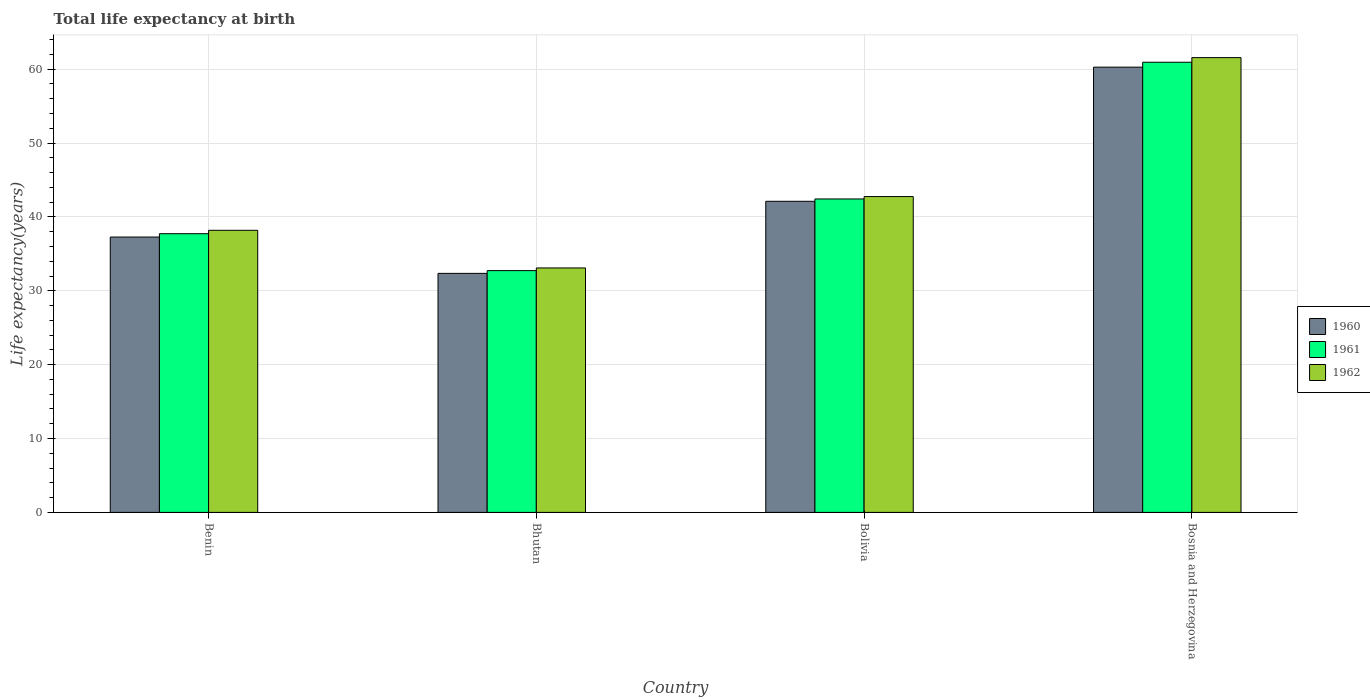Are the number of bars on each tick of the X-axis equal?
Offer a very short reply. Yes. What is the label of the 2nd group of bars from the left?
Provide a succinct answer. Bhutan. In how many cases, is the number of bars for a given country not equal to the number of legend labels?
Give a very brief answer. 0. What is the life expectancy at birth in in 1960 in Bhutan?
Your answer should be very brief. 32.36. Across all countries, what is the maximum life expectancy at birth in in 1961?
Offer a terse response. 60.94. Across all countries, what is the minimum life expectancy at birth in in 1962?
Give a very brief answer. 33.09. In which country was the life expectancy at birth in in 1961 maximum?
Ensure brevity in your answer.  Bosnia and Herzegovina. In which country was the life expectancy at birth in in 1960 minimum?
Make the answer very short. Bhutan. What is the total life expectancy at birth in in 1960 in the graph?
Your response must be concise. 172.03. What is the difference between the life expectancy at birth in in 1962 in Bhutan and that in Bolivia?
Ensure brevity in your answer.  -9.66. What is the difference between the life expectancy at birth in in 1961 in Bolivia and the life expectancy at birth in in 1962 in Bhutan?
Your answer should be very brief. 9.34. What is the average life expectancy at birth in in 1961 per country?
Your answer should be very brief. 43.46. What is the difference between the life expectancy at birth in of/in 1960 and life expectancy at birth in of/in 1961 in Benin?
Provide a short and direct response. -0.45. In how many countries, is the life expectancy at birth in in 1961 greater than 58 years?
Provide a succinct answer. 1. What is the ratio of the life expectancy at birth in in 1960 in Benin to that in Bolivia?
Ensure brevity in your answer.  0.89. Is the difference between the life expectancy at birth in in 1960 in Benin and Bosnia and Herzegovina greater than the difference between the life expectancy at birth in in 1961 in Benin and Bosnia and Herzegovina?
Ensure brevity in your answer.  Yes. What is the difference between the highest and the second highest life expectancy at birth in in 1962?
Ensure brevity in your answer.  -18.81. What is the difference between the highest and the lowest life expectancy at birth in in 1962?
Offer a very short reply. 28.47. In how many countries, is the life expectancy at birth in in 1960 greater than the average life expectancy at birth in in 1960 taken over all countries?
Offer a terse response. 1. Is the sum of the life expectancy at birth in in 1961 in Benin and Bosnia and Herzegovina greater than the maximum life expectancy at birth in in 1960 across all countries?
Give a very brief answer. Yes. Is it the case that in every country, the sum of the life expectancy at birth in in 1960 and life expectancy at birth in in 1962 is greater than the life expectancy at birth in in 1961?
Your answer should be very brief. Yes. How many bars are there?
Offer a terse response. 12. How many countries are there in the graph?
Your answer should be very brief. 4. How are the legend labels stacked?
Ensure brevity in your answer.  Vertical. What is the title of the graph?
Your answer should be very brief. Total life expectancy at birth. Does "1971" appear as one of the legend labels in the graph?
Your answer should be very brief. No. What is the label or title of the Y-axis?
Your response must be concise. Life expectancy(years). What is the Life expectancy(years) in 1960 in Benin?
Provide a short and direct response. 37.28. What is the Life expectancy(years) of 1961 in Benin?
Offer a very short reply. 37.73. What is the Life expectancy(years) of 1962 in Benin?
Keep it short and to the point. 38.19. What is the Life expectancy(years) in 1960 in Bhutan?
Keep it short and to the point. 32.36. What is the Life expectancy(years) in 1961 in Bhutan?
Your answer should be very brief. 32.73. What is the Life expectancy(years) in 1962 in Bhutan?
Ensure brevity in your answer.  33.09. What is the Life expectancy(years) of 1960 in Bolivia?
Your response must be concise. 42.12. What is the Life expectancy(years) of 1961 in Bolivia?
Ensure brevity in your answer.  42.43. What is the Life expectancy(years) in 1962 in Bolivia?
Ensure brevity in your answer.  42.76. What is the Life expectancy(years) of 1960 in Bosnia and Herzegovina?
Your answer should be very brief. 60.28. What is the Life expectancy(years) of 1961 in Bosnia and Herzegovina?
Your response must be concise. 60.94. What is the Life expectancy(years) of 1962 in Bosnia and Herzegovina?
Provide a short and direct response. 61.57. Across all countries, what is the maximum Life expectancy(years) in 1960?
Provide a short and direct response. 60.28. Across all countries, what is the maximum Life expectancy(years) of 1961?
Provide a short and direct response. 60.94. Across all countries, what is the maximum Life expectancy(years) in 1962?
Ensure brevity in your answer.  61.57. Across all countries, what is the minimum Life expectancy(years) in 1960?
Give a very brief answer. 32.36. Across all countries, what is the minimum Life expectancy(years) of 1961?
Keep it short and to the point. 32.73. Across all countries, what is the minimum Life expectancy(years) in 1962?
Offer a very short reply. 33.09. What is the total Life expectancy(years) of 1960 in the graph?
Your response must be concise. 172.03. What is the total Life expectancy(years) in 1961 in the graph?
Offer a terse response. 173.84. What is the total Life expectancy(years) of 1962 in the graph?
Offer a terse response. 175.61. What is the difference between the Life expectancy(years) of 1960 in Benin and that in Bhutan?
Give a very brief answer. 4.92. What is the difference between the Life expectancy(years) of 1961 in Benin and that in Bhutan?
Your answer should be compact. 5. What is the difference between the Life expectancy(years) in 1962 in Benin and that in Bhutan?
Make the answer very short. 5.1. What is the difference between the Life expectancy(years) of 1960 in Benin and that in Bolivia?
Offer a terse response. -4.84. What is the difference between the Life expectancy(years) in 1961 in Benin and that in Bolivia?
Provide a short and direct response. -4.7. What is the difference between the Life expectancy(years) in 1962 in Benin and that in Bolivia?
Ensure brevity in your answer.  -4.57. What is the difference between the Life expectancy(years) in 1960 in Benin and that in Bosnia and Herzegovina?
Offer a very short reply. -23. What is the difference between the Life expectancy(years) in 1961 in Benin and that in Bosnia and Herzegovina?
Provide a succinct answer. -23.21. What is the difference between the Life expectancy(years) in 1962 in Benin and that in Bosnia and Herzegovina?
Ensure brevity in your answer.  -23.38. What is the difference between the Life expectancy(years) of 1960 in Bhutan and that in Bolivia?
Your answer should be compact. -9.76. What is the difference between the Life expectancy(years) in 1961 in Bhutan and that in Bolivia?
Make the answer very short. -9.7. What is the difference between the Life expectancy(years) in 1962 in Bhutan and that in Bolivia?
Give a very brief answer. -9.66. What is the difference between the Life expectancy(years) of 1960 in Bhutan and that in Bosnia and Herzegovina?
Offer a terse response. -27.92. What is the difference between the Life expectancy(years) in 1961 in Bhutan and that in Bosnia and Herzegovina?
Your response must be concise. -28.21. What is the difference between the Life expectancy(years) of 1962 in Bhutan and that in Bosnia and Herzegovina?
Give a very brief answer. -28.47. What is the difference between the Life expectancy(years) of 1960 in Bolivia and that in Bosnia and Herzegovina?
Provide a short and direct response. -18.16. What is the difference between the Life expectancy(years) of 1961 in Bolivia and that in Bosnia and Herzegovina?
Offer a very short reply. -18.51. What is the difference between the Life expectancy(years) of 1962 in Bolivia and that in Bosnia and Herzegovina?
Your response must be concise. -18.81. What is the difference between the Life expectancy(years) of 1960 in Benin and the Life expectancy(years) of 1961 in Bhutan?
Your answer should be compact. 4.55. What is the difference between the Life expectancy(years) of 1960 in Benin and the Life expectancy(years) of 1962 in Bhutan?
Ensure brevity in your answer.  4.18. What is the difference between the Life expectancy(years) in 1961 in Benin and the Life expectancy(years) in 1962 in Bhutan?
Your response must be concise. 4.64. What is the difference between the Life expectancy(years) of 1960 in Benin and the Life expectancy(years) of 1961 in Bolivia?
Keep it short and to the point. -5.16. What is the difference between the Life expectancy(years) in 1960 in Benin and the Life expectancy(years) in 1962 in Bolivia?
Provide a succinct answer. -5.48. What is the difference between the Life expectancy(years) of 1961 in Benin and the Life expectancy(years) of 1962 in Bolivia?
Make the answer very short. -5.03. What is the difference between the Life expectancy(years) in 1960 in Benin and the Life expectancy(years) in 1961 in Bosnia and Herzegovina?
Your response must be concise. -23.66. What is the difference between the Life expectancy(years) of 1960 in Benin and the Life expectancy(years) of 1962 in Bosnia and Herzegovina?
Make the answer very short. -24.29. What is the difference between the Life expectancy(years) of 1961 in Benin and the Life expectancy(years) of 1962 in Bosnia and Herzegovina?
Provide a succinct answer. -23.84. What is the difference between the Life expectancy(years) of 1960 in Bhutan and the Life expectancy(years) of 1961 in Bolivia?
Provide a short and direct response. -10.07. What is the difference between the Life expectancy(years) of 1960 in Bhutan and the Life expectancy(years) of 1962 in Bolivia?
Provide a succinct answer. -10.4. What is the difference between the Life expectancy(years) of 1961 in Bhutan and the Life expectancy(years) of 1962 in Bolivia?
Offer a very short reply. -10.03. What is the difference between the Life expectancy(years) of 1960 in Bhutan and the Life expectancy(years) of 1961 in Bosnia and Herzegovina?
Your response must be concise. -28.58. What is the difference between the Life expectancy(years) in 1960 in Bhutan and the Life expectancy(years) in 1962 in Bosnia and Herzegovina?
Offer a terse response. -29.21. What is the difference between the Life expectancy(years) of 1961 in Bhutan and the Life expectancy(years) of 1962 in Bosnia and Herzegovina?
Your response must be concise. -28.84. What is the difference between the Life expectancy(years) of 1960 in Bolivia and the Life expectancy(years) of 1961 in Bosnia and Herzegovina?
Keep it short and to the point. -18.82. What is the difference between the Life expectancy(years) in 1960 in Bolivia and the Life expectancy(years) in 1962 in Bosnia and Herzegovina?
Provide a short and direct response. -19.45. What is the difference between the Life expectancy(years) in 1961 in Bolivia and the Life expectancy(years) in 1962 in Bosnia and Herzegovina?
Give a very brief answer. -19.13. What is the average Life expectancy(years) of 1960 per country?
Provide a succinct answer. 43.01. What is the average Life expectancy(years) in 1961 per country?
Provide a succinct answer. 43.46. What is the average Life expectancy(years) of 1962 per country?
Your answer should be compact. 43.9. What is the difference between the Life expectancy(years) of 1960 and Life expectancy(years) of 1961 in Benin?
Offer a terse response. -0.45. What is the difference between the Life expectancy(years) of 1960 and Life expectancy(years) of 1962 in Benin?
Keep it short and to the point. -0.91. What is the difference between the Life expectancy(years) of 1961 and Life expectancy(years) of 1962 in Benin?
Give a very brief answer. -0.46. What is the difference between the Life expectancy(years) in 1960 and Life expectancy(years) in 1961 in Bhutan?
Offer a very short reply. -0.37. What is the difference between the Life expectancy(years) of 1960 and Life expectancy(years) of 1962 in Bhutan?
Give a very brief answer. -0.73. What is the difference between the Life expectancy(years) in 1961 and Life expectancy(years) in 1962 in Bhutan?
Offer a very short reply. -0.36. What is the difference between the Life expectancy(years) of 1960 and Life expectancy(years) of 1961 in Bolivia?
Offer a terse response. -0.32. What is the difference between the Life expectancy(years) in 1960 and Life expectancy(years) in 1962 in Bolivia?
Your answer should be very brief. -0.64. What is the difference between the Life expectancy(years) in 1961 and Life expectancy(years) in 1962 in Bolivia?
Provide a succinct answer. -0.32. What is the difference between the Life expectancy(years) of 1960 and Life expectancy(years) of 1961 in Bosnia and Herzegovina?
Your answer should be compact. -0.67. What is the difference between the Life expectancy(years) of 1960 and Life expectancy(years) of 1962 in Bosnia and Herzegovina?
Offer a terse response. -1.29. What is the difference between the Life expectancy(years) of 1961 and Life expectancy(years) of 1962 in Bosnia and Herzegovina?
Provide a short and direct response. -0.63. What is the ratio of the Life expectancy(years) of 1960 in Benin to that in Bhutan?
Your answer should be compact. 1.15. What is the ratio of the Life expectancy(years) in 1961 in Benin to that in Bhutan?
Make the answer very short. 1.15. What is the ratio of the Life expectancy(years) of 1962 in Benin to that in Bhutan?
Give a very brief answer. 1.15. What is the ratio of the Life expectancy(years) in 1960 in Benin to that in Bolivia?
Ensure brevity in your answer.  0.89. What is the ratio of the Life expectancy(years) of 1961 in Benin to that in Bolivia?
Your answer should be compact. 0.89. What is the ratio of the Life expectancy(years) in 1962 in Benin to that in Bolivia?
Your answer should be very brief. 0.89. What is the ratio of the Life expectancy(years) of 1960 in Benin to that in Bosnia and Herzegovina?
Provide a short and direct response. 0.62. What is the ratio of the Life expectancy(years) of 1961 in Benin to that in Bosnia and Herzegovina?
Make the answer very short. 0.62. What is the ratio of the Life expectancy(years) in 1962 in Benin to that in Bosnia and Herzegovina?
Ensure brevity in your answer.  0.62. What is the ratio of the Life expectancy(years) of 1960 in Bhutan to that in Bolivia?
Offer a very short reply. 0.77. What is the ratio of the Life expectancy(years) of 1961 in Bhutan to that in Bolivia?
Give a very brief answer. 0.77. What is the ratio of the Life expectancy(years) of 1962 in Bhutan to that in Bolivia?
Offer a terse response. 0.77. What is the ratio of the Life expectancy(years) in 1960 in Bhutan to that in Bosnia and Herzegovina?
Give a very brief answer. 0.54. What is the ratio of the Life expectancy(years) in 1961 in Bhutan to that in Bosnia and Herzegovina?
Offer a very short reply. 0.54. What is the ratio of the Life expectancy(years) in 1962 in Bhutan to that in Bosnia and Herzegovina?
Keep it short and to the point. 0.54. What is the ratio of the Life expectancy(years) in 1960 in Bolivia to that in Bosnia and Herzegovina?
Offer a terse response. 0.7. What is the ratio of the Life expectancy(years) of 1961 in Bolivia to that in Bosnia and Herzegovina?
Make the answer very short. 0.7. What is the ratio of the Life expectancy(years) in 1962 in Bolivia to that in Bosnia and Herzegovina?
Offer a terse response. 0.69. What is the difference between the highest and the second highest Life expectancy(years) of 1960?
Give a very brief answer. 18.16. What is the difference between the highest and the second highest Life expectancy(years) in 1961?
Offer a very short reply. 18.51. What is the difference between the highest and the second highest Life expectancy(years) of 1962?
Provide a short and direct response. 18.81. What is the difference between the highest and the lowest Life expectancy(years) in 1960?
Keep it short and to the point. 27.92. What is the difference between the highest and the lowest Life expectancy(years) in 1961?
Your answer should be very brief. 28.21. What is the difference between the highest and the lowest Life expectancy(years) of 1962?
Provide a short and direct response. 28.47. 